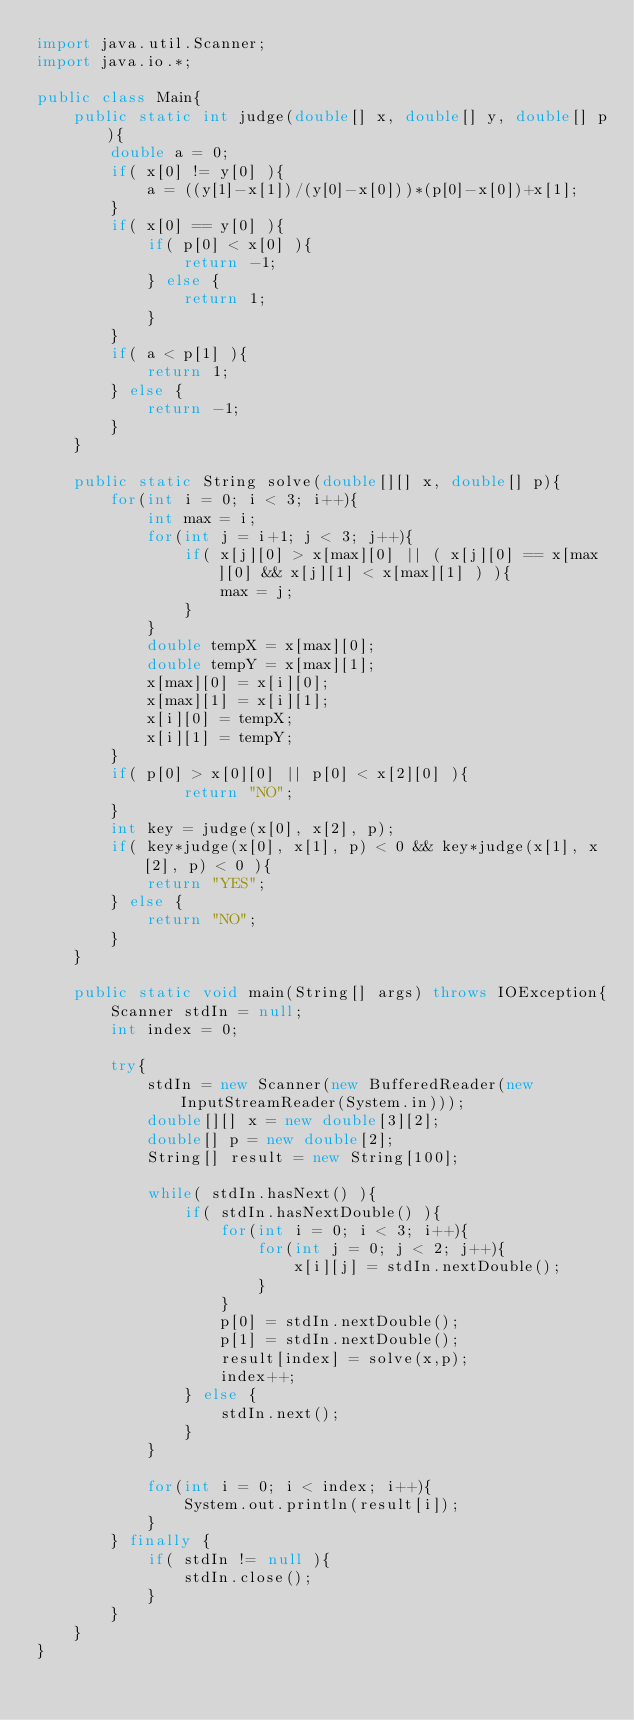<code> <loc_0><loc_0><loc_500><loc_500><_Java_>import java.util.Scanner;
import java.io.*;

public class Main{
	public static int judge(double[] x, double[] y, double[] p){
		double a = 0;
		if( x[0] != y[0] ){
			a = ((y[1]-x[1])/(y[0]-x[0]))*(p[0]-x[0])+x[1];
		}
		if( x[0] == y[0] ){
			if( p[0] < x[0] ){
				return -1;
			} else {
				return 1;
			}
		}
		if( a < p[1] ){
			return 1;
		} else {
			return -1;
		}
	}
		
	public static String solve(double[][] x, double[] p){
		for(int i = 0; i < 3; i++){
			int max = i;
			for(int j = i+1; j < 3; j++){
				if( x[j][0] > x[max][0] || ( x[j][0] == x[max][0] && x[j][1] < x[max][1] ) ){
					max = j;
				}
			}
			double tempX = x[max][0];
			double tempY = x[max][1];
			x[max][0] = x[i][0];
			x[max][1] = x[i][1];
			x[i][0] = tempX;
			x[i][1] = tempY;
		}
		if( p[0] > x[0][0] || p[0] < x[2][0] ){
				return "NO";
		}
		int key = judge(x[0], x[2], p);
		if( key*judge(x[0], x[1], p) < 0 && key*judge(x[1], x[2], p) < 0 ){
			return "YES";
		} else {
			return "NO";
		}
	}
	
	public static void main(String[] args) throws IOException{
		Scanner stdIn = null;
		int index = 0;
		
		try{
			stdIn = new Scanner(new BufferedReader(new InputStreamReader(System.in)));
			double[][] x = new double[3][2];
			double[] p = new double[2];
			String[] result = new String[100];
			
			while( stdIn.hasNext() ){
				if( stdIn.hasNextDouble() ){
					for(int i = 0; i < 3; i++){
						for(int j = 0; j < 2; j++){
							x[i][j] = stdIn.nextDouble();
						}
					}
					p[0] = stdIn.nextDouble();
					p[1] = stdIn.nextDouble();
					result[index] = solve(x,p);
					index++;
				} else {
					stdIn.next();
				}
			}
			
			for(int i = 0; i < index; i++){
				System.out.println(result[i]);
			}
		} finally {
			if( stdIn != null ){
				stdIn.close();
			}
		}
	}
}</code> 